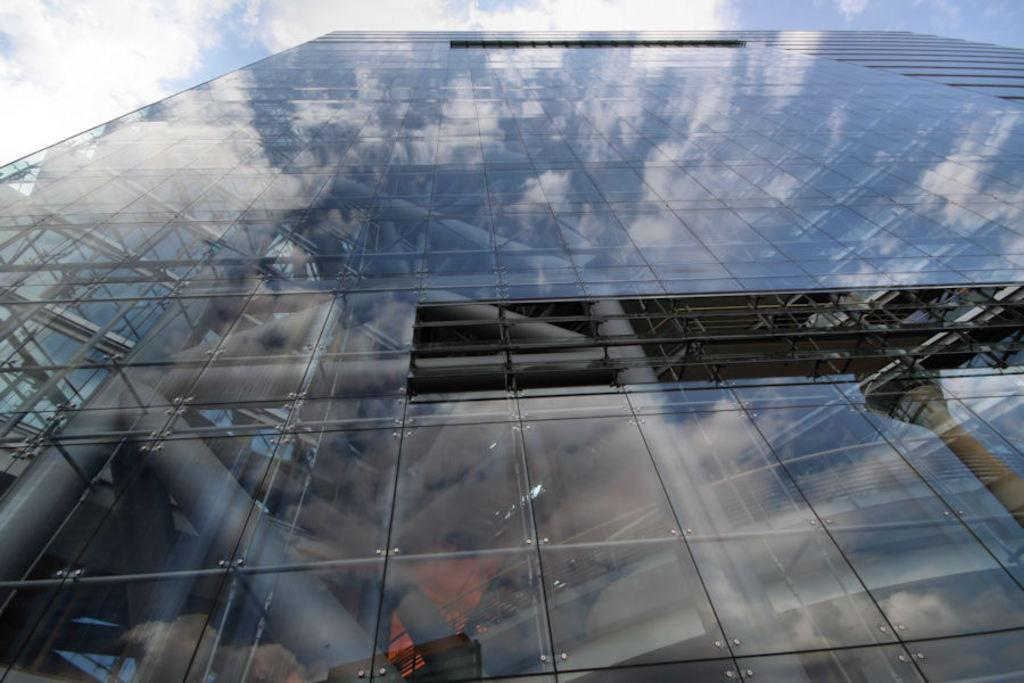What type of building is featured in the image? There is a glass building in the image. What can be seen in the reflection on the glass building? The glass building has a reflection of the sky. What is the condition of the sky in the reflection? The sky in the reflection has clouds. What other structure is visible in the image? There is a tower visible in the image. How does the glass building contribute to the harmony of the environment in the image? The image does not provide information about the harmony of the environment, so it is not possible to determine how the glass building contributes to it. 